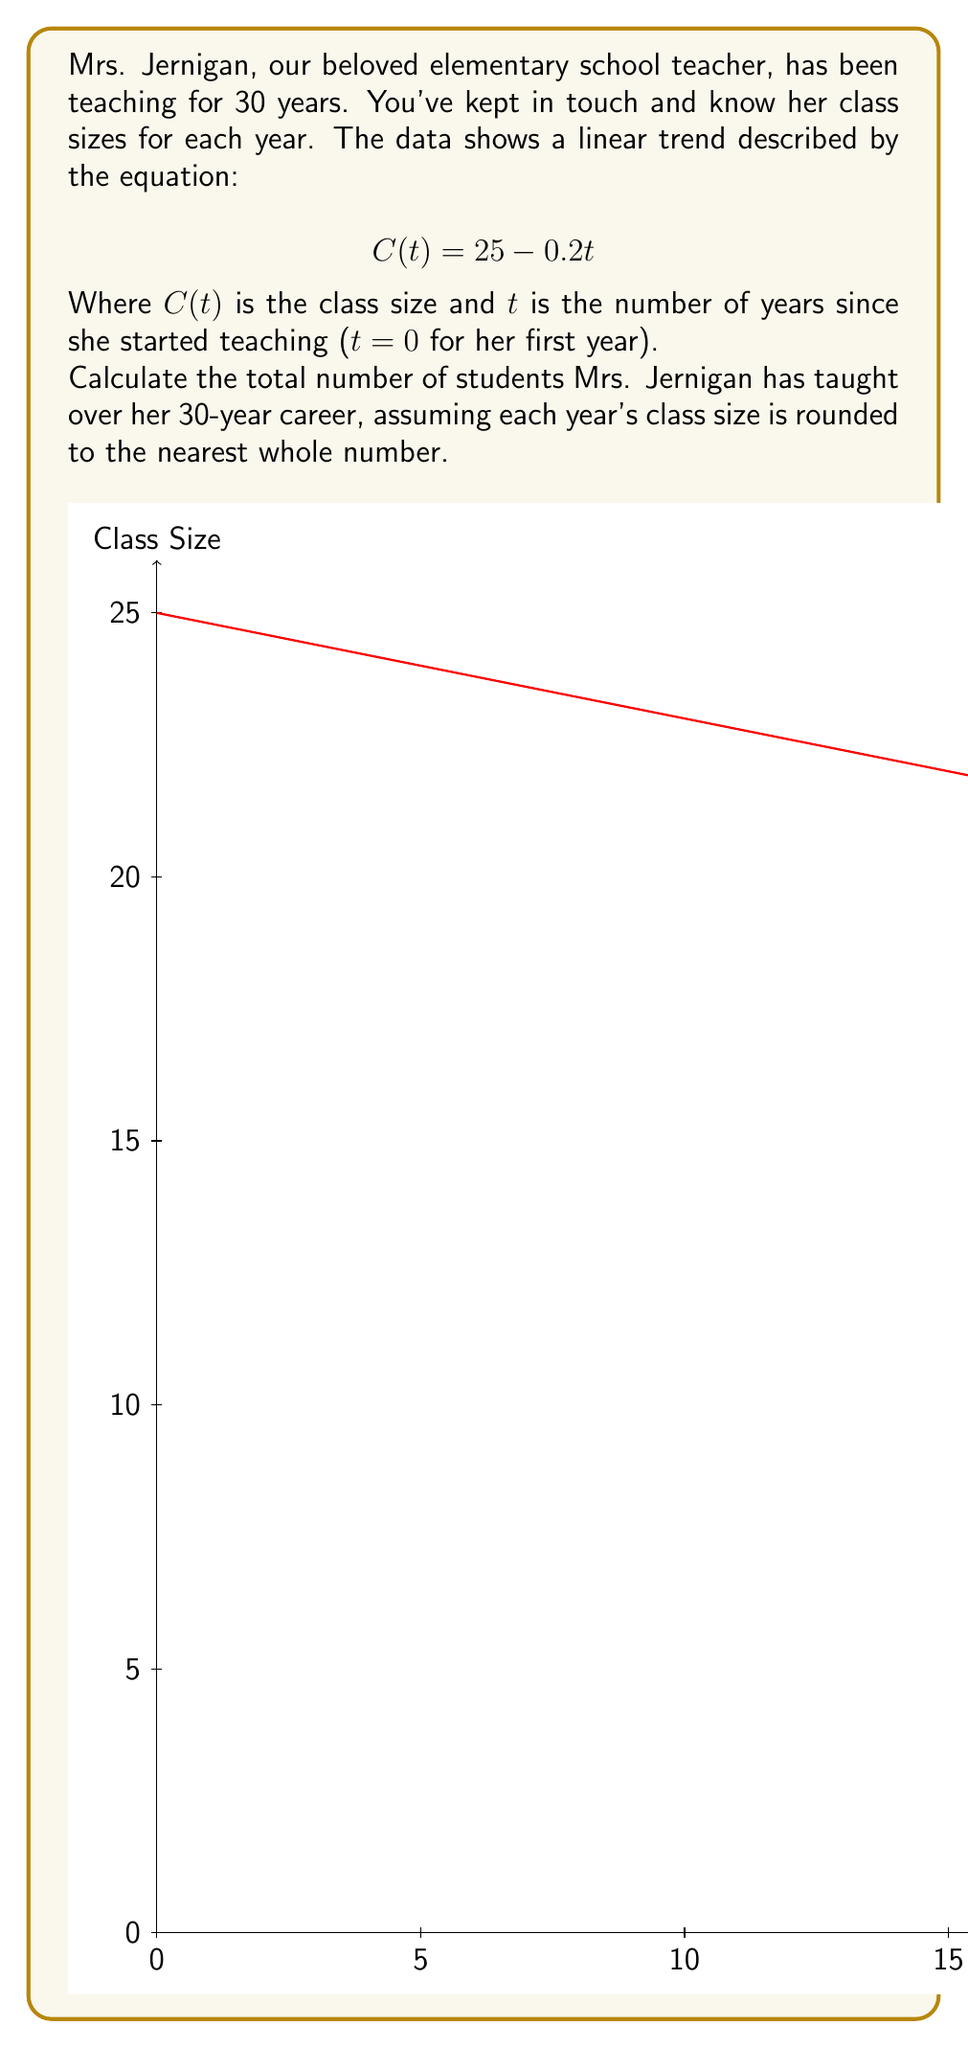Show me your answer to this math problem. Let's approach this step-by-step:

1) First, we need to calculate the class size for each year:
   For t = 0 (first year): $C(0) = 25 - 0.2(0) = 25$
   For t = 1 (second year): $C(1) = 25 - 0.2(1) = 24.8$
   ...and so on until t = 29 (30th year)

2) We need to round each class size to the nearest whole number:
   Year 1: 25 students
   Year 2: 25 students (24.8 rounds to 25)
   Year 3: 24 students (24.6 rounds to 25)
   ...

3) To find the total number of students, we need to sum up these rounded values.

4) Instead of calculating each year individually, we can use the arithmetic sequence formula:
   $$S_n = \frac{n}{2}(a_1 + a_n)$$
   Where $S_n$ is the sum, $n$ is the number of terms, $a_1$ is the first term, and $a_n$ is the last term.

5) In our case:
   $n = 30$ (30 years)
   $a_1 = 25$ (first year class size)
   $a_{30} = round(25 - 0.2(29)) = round(19.2) = 19$ (30th year class size)

6) Plugging into the formula:
   $$S_{30} = \frac{30}{2}(25 + 19) = 15(44) = 660$$

Therefore, Mrs. Jernigan has taught a total of 660 students over her 30-year career.
Answer: 660 students 